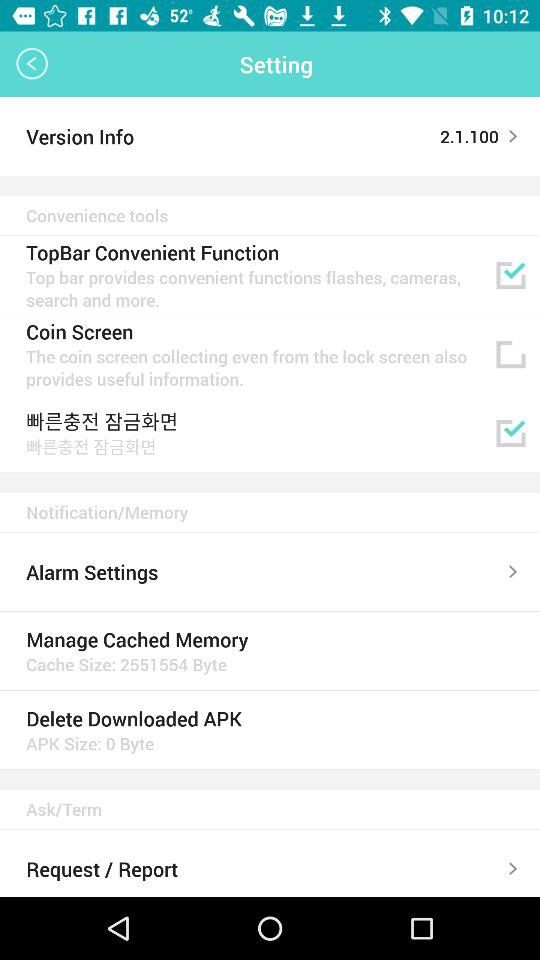What is the status of "Coin Screen"? The status is "off". 